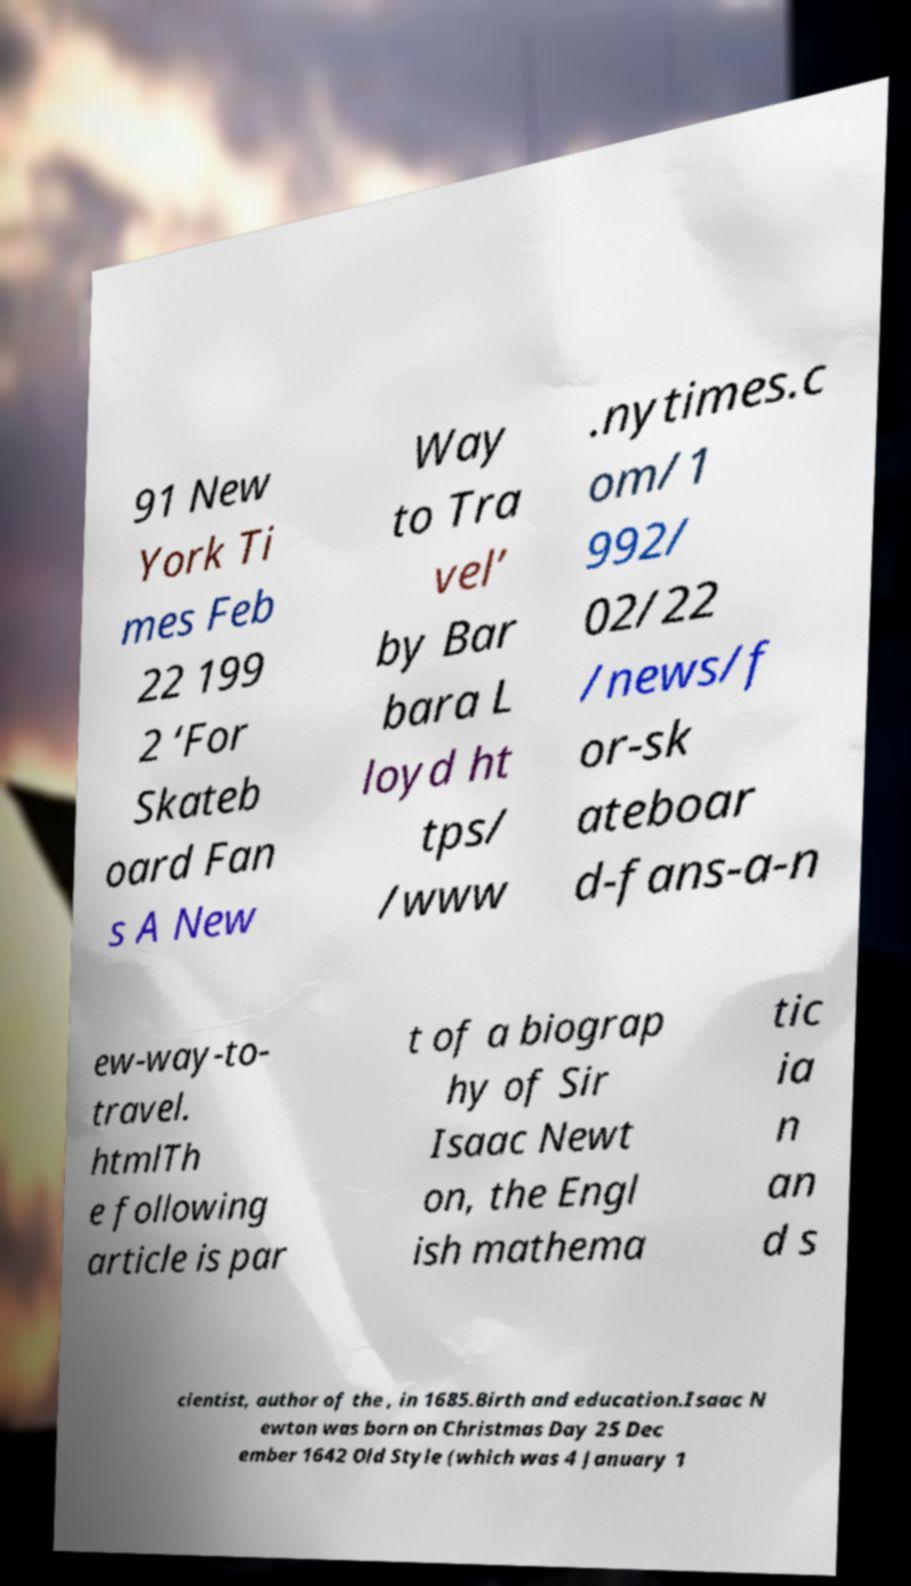Could you assist in decoding the text presented in this image and type it out clearly? 91 New York Ti mes Feb 22 199 2 ‘For Skateb oard Fan s A New Way to Tra vel’ by Bar bara L loyd ht tps/ /www .nytimes.c om/1 992/ 02/22 /news/f or-sk ateboar d-fans-a-n ew-way-to- travel. htmlTh e following article is par t of a biograp hy of Sir Isaac Newt on, the Engl ish mathema tic ia n an d s cientist, author of the , in 1685.Birth and education.Isaac N ewton was born on Christmas Day 25 Dec ember 1642 Old Style (which was 4 January 1 